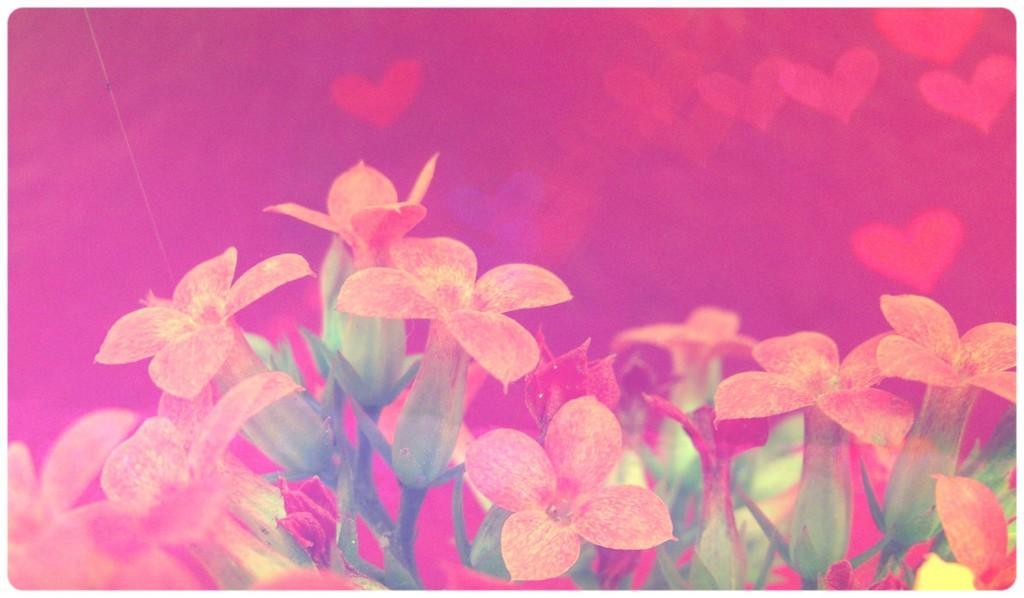Can you describe this image briefly? This is edited image, we can see flowers. In the background it is pink. 